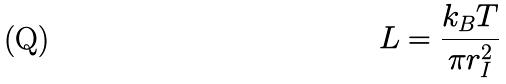<formula> <loc_0><loc_0><loc_500><loc_500>L = \frac { k _ { B } T } { \pi r _ { I } ^ { 2 } }</formula> 